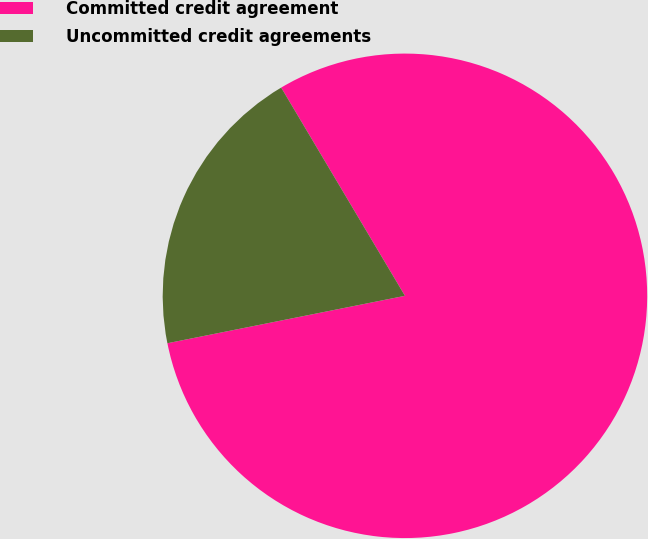Convert chart to OTSL. <chart><loc_0><loc_0><loc_500><loc_500><pie_chart><fcel>Committed credit agreement<fcel>Uncommitted credit agreements<nl><fcel>80.4%<fcel>19.6%<nl></chart> 